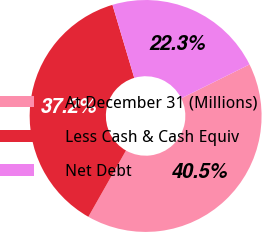<chart> <loc_0><loc_0><loc_500><loc_500><pie_chart><fcel>At December 31 (Millions)<fcel>Less Cash & Cash Equiv<fcel>Net Debt<nl><fcel>40.55%<fcel>37.17%<fcel>22.29%<nl></chart> 